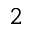<formula> <loc_0><loc_0><loc_500><loc_500>2</formula> 